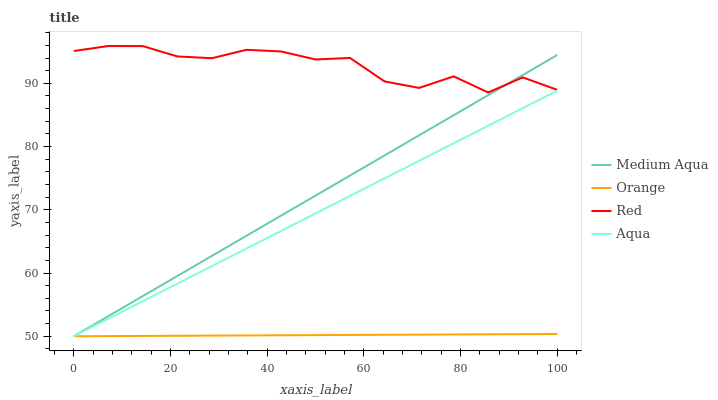Does Orange have the minimum area under the curve?
Answer yes or no. Yes. Does Red have the maximum area under the curve?
Answer yes or no. Yes. Does Aqua have the minimum area under the curve?
Answer yes or no. No. Does Aqua have the maximum area under the curve?
Answer yes or no. No. Is Orange the smoothest?
Answer yes or no. Yes. Is Red the roughest?
Answer yes or no. Yes. Is Aqua the smoothest?
Answer yes or no. No. Is Aqua the roughest?
Answer yes or no. No. Does Red have the lowest value?
Answer yes or no. No. Does Red have the highest value?
Answer yes or no. Yes. Does Aqua have the highest value?
Answer yes or no. No. Is Orange less than Red?
Answer yes or no. Yes. Is Red greater than Orange?
Answer yes or no. Yes. Does Orange intersect Red?
Answer yes or no. No. 